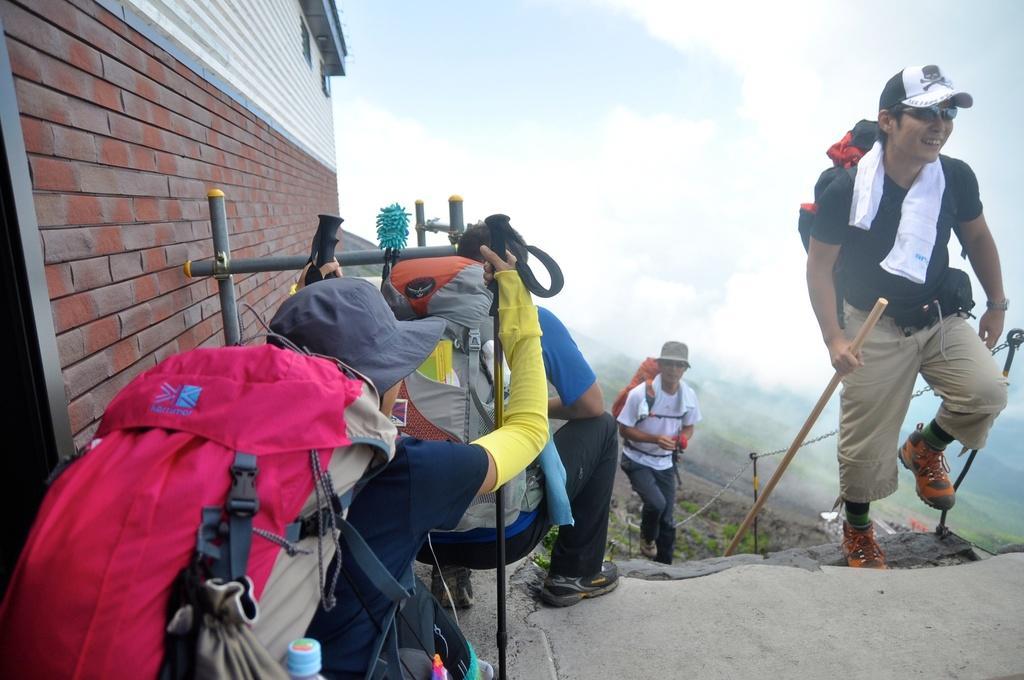How would you summarize this image in a sentence or two? This is building. This man is climbing, as there is a leg movement and holding a stick. These persons are in squad position. This man is walking as there is a leg movement. These two persons wore luggage. 